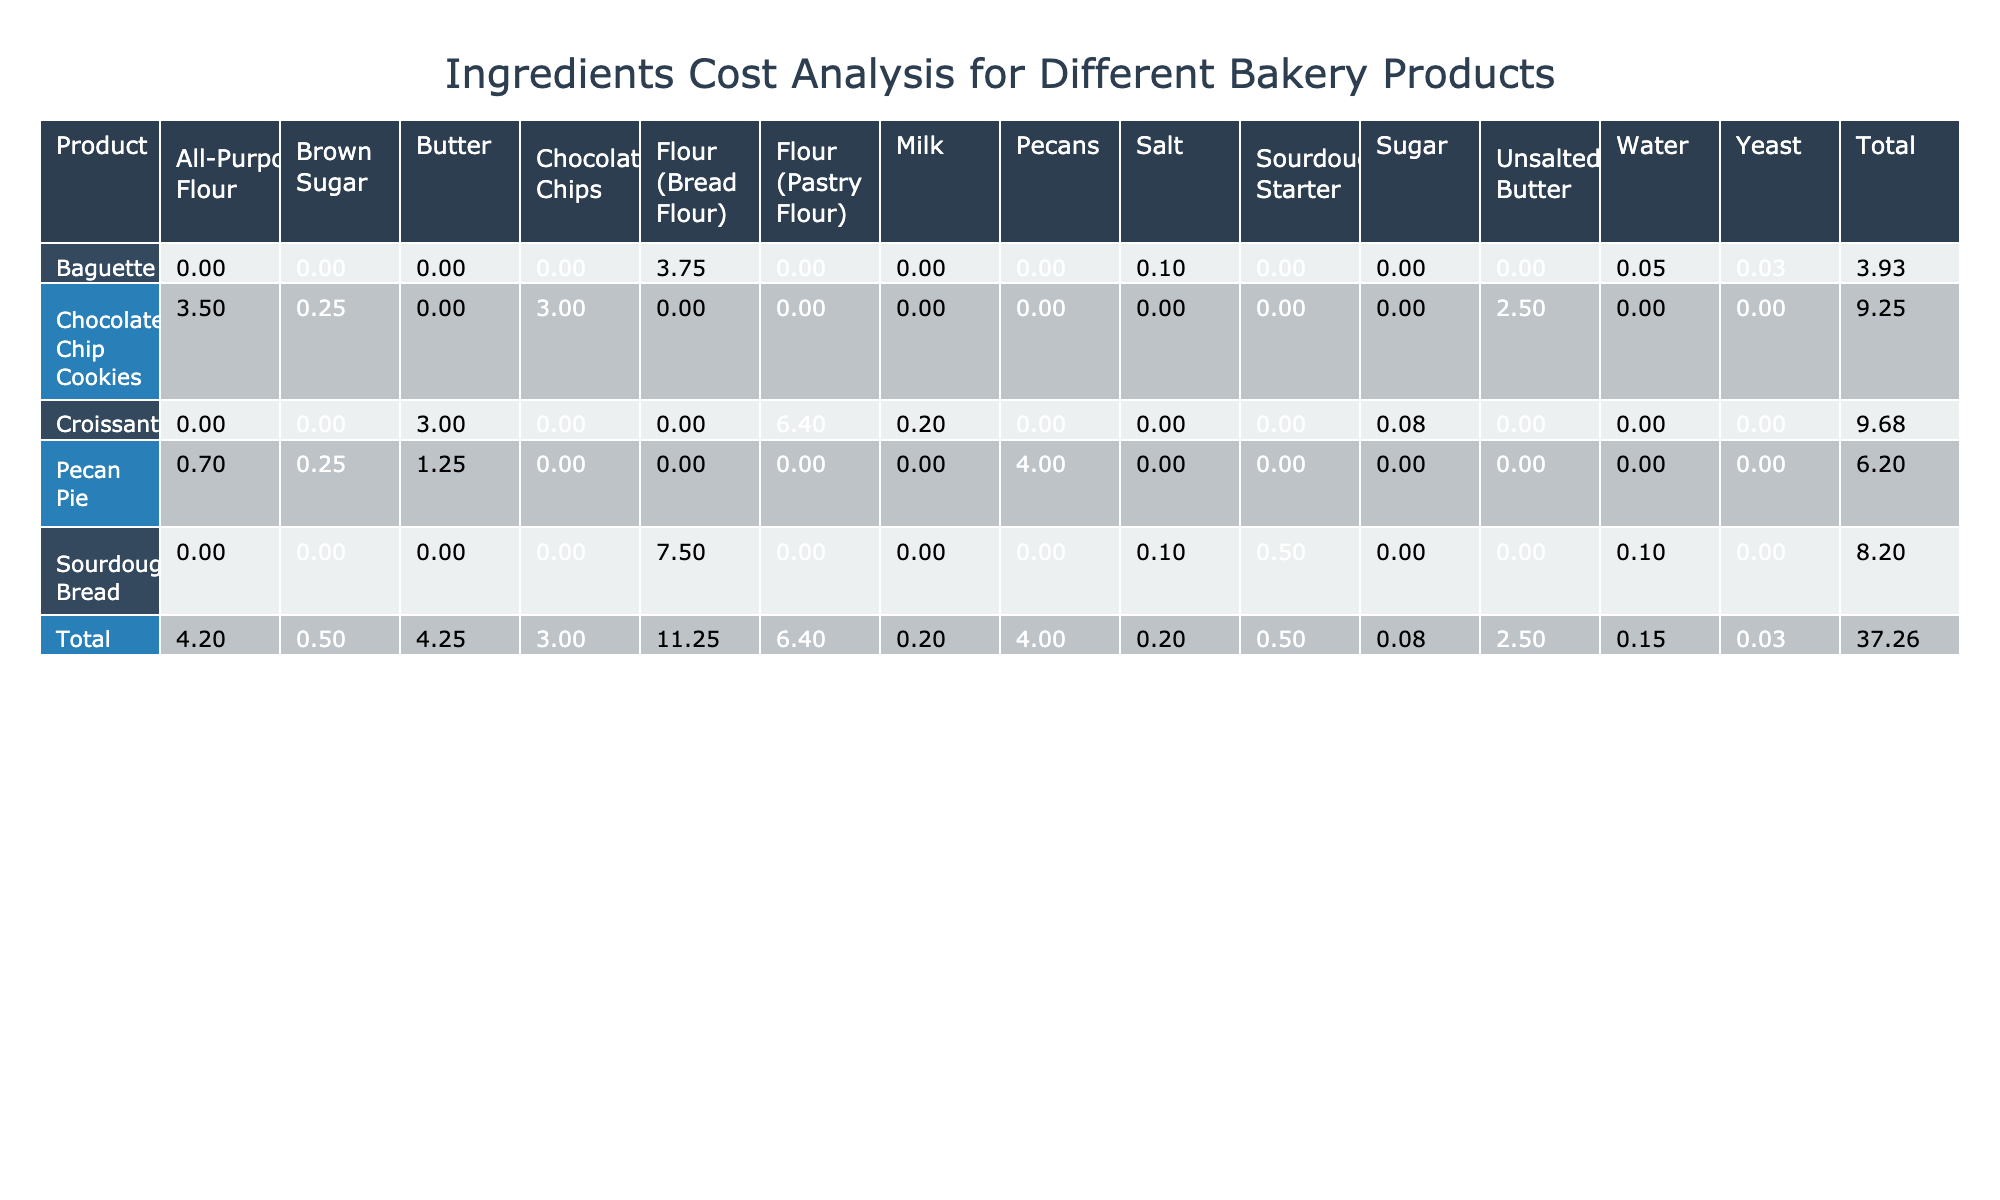What is the total cost of making a batch of Sourdough Bread? To find the total cost of Sourdough Bread, we look at the 'Total Cost ($)' column for this product. The values are 7.50, 0.10, 0.10, and 0.50. Adding these gives us 7.50 + 0.10 + 0.10 + 0.50 = 8.20.
Answer: 8.20 Which ingredient has the highest unit price in the table? We need to check the 'Unit Price ($)' column for all ingredients listed. Comparing the prices, the highest value is 4.00, corresponding to Pecans used in Pecan Pie.
Answer: 4.00 Is the total cost of Croissant greater than that of Baguette? First, we find the total cost of Croissant, which is 6.40 + 3.00 + 0.20 + 0.08 = 9.68. Next, the total cost for Baguette is 3.75 + 0.05 + 0.03 + 0.10 = 3.93. Since 9.68 > 3.93, the statement is true.
Answer: Yes What is the total cost of all ingredients used in Chocolate Chip Cookies? The total cost of the ingredients for Chocolate Chip Cookies can be found by summing the values: 3.50 + 0.25 + 2.50 + 3.00 = 9.25. Therefore, the total cost for this product is 9.25.
Answer: 9.25 Which product has the lowest total cost of ingredients? By comparing the total costs of all products, we note Sourdough Bread has a total of 8.20, Pecan Pie has 6.20, and Chocolate Chip Cookies has 9.25. The product with the lowest total cost is Pecan Pie, which totals 6.20.
Answer: Pecan Pie What is the average unit price of all ingredients used in Croissant? To find the average unit price, we list the prices: 0.80 (Flour), 3.00 (Butter), 0.05 (Milk), 0.15 (Sugar). Summing the prices gives 0.80 + 3.00 + 0.05 + 0.15 = 4.00. With 4 ingredients, we divide by 4: 4.00 / 4 = 1.00.
Answer: 1.00 Is the total cost of Sourdough Starter more than that of Yeast used in Baguette? The cost of Sourdough Starter is 0.50, while the cost of Yeast is 0.03. Since 0.50 > 0.03, the statement is true.
Answer: Yes How many products have a total cost over 9 dollars? We analyze the total costs: Sourdough Bread (8.20), Croissant (9.68), Chocolate Chip Cookies (9.25), Baguette (3.93), and Pecan Pie (6.20). Only Croissant and Chocolate Chip Cookies exceed 9 dollars, so there are 2 products.
Answer: 2 